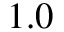<formula> <loc_0><loc_0><loc_500><loc_500>1 . 0</formula> 